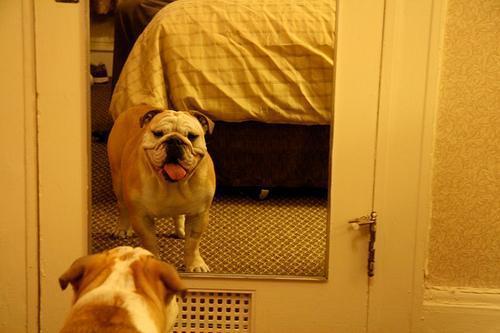How many bulldogs are there?
Give a very brief answer. 1. How many dogs are there?
Give a very brief answer. 1. 